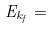Convert formula to latex. <formula><loc_0><loc_0><loc_500><loc_500>E _ { k _ { f } } =</formula> 